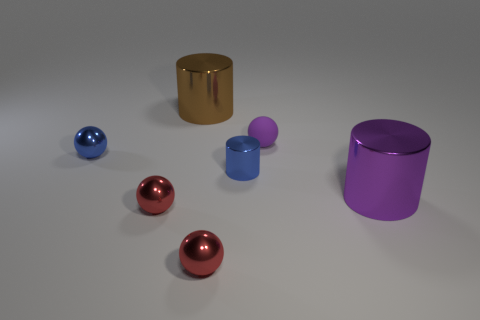What number of small shiny objects are the same shape as the big brown metallic thing?
Give a very brief answer. 1. Does the purple rubber sphere have the same size as the cylinder that is to the right of the tiny purple sphere?
Offer a terse response. No. Does the purple metallic thing have the same size as the blue sphere?
Offer a very short reply. No. Is the shape of the small purple matte object the same as the brown object?
Offer a terse response. No. There is a shiny object that is behind the purple thing behind the big shiny cylinder that is to the right of the blue metal cylinder; what size is it?
Make the answer very short. Large. What is the small purple object made of?
Offer a very short reply. Rubber. The shiny object that is the same color as the small metallic cylinder is what size?
Provide a short and direct response. Small. There is a rubber object; does it have the same shape as the shiny object that is on the right side of the blue metal cylinder?
Offer a very short reply. No. What material is the large cylinder that is left of the metal thing that is to the right of the purple object that is behind the purple cylinder?
Give a very brief answer. Metal. What number of gray rubber blocks are there?
Ensure brevity in your answer.  0. 